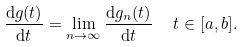Convert formula to latex. <formula><loc_0><loc_0><loc_500><loc_500>\frac { \mathrm d g ( t ) } { \mathrm d t } & = \lim _ { n \to \infty } \frac { \mathrm d g _ { n } ( t ) } { \mathrm d t } \quad \ t \in [ a , b ] .</formula> 